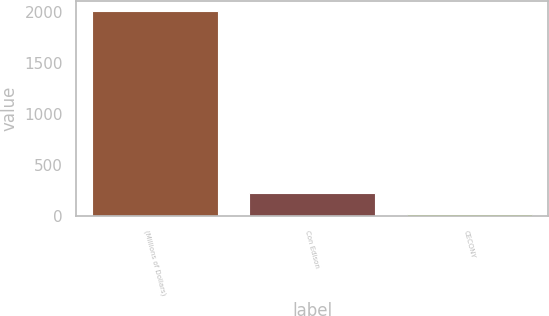Convert chart. <chart><loc_0><loc_0><loc_500><loc_500><bar_chart><fcel>(Millions of Dollars)<fcel>Con Edison<fcel>CECONY<nl><fcel>2009<fcel>223.4<fcel>25<nl></chart> 